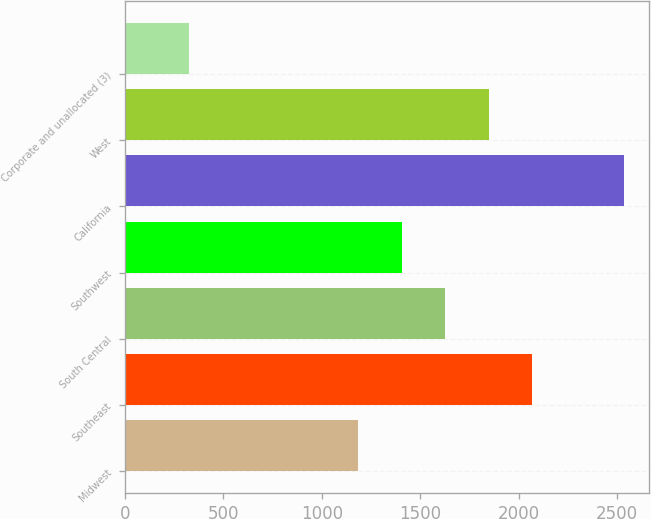<chart> <loc_0><loc_0><loc_500><loc_500><bar_chart><fcel>Midwest<fcel>Southeast<fcel>South Central<fcel>Southwest<fcel>California<fcel>West<fcel>Corporate and unallocated (3)<nl><fcel>1185.1<fcel>2068.54<fcel>1626.82<fcel>1405.96<fcel>2535.7<fcel>1847.68<fcel>327.1<nl></chart> 